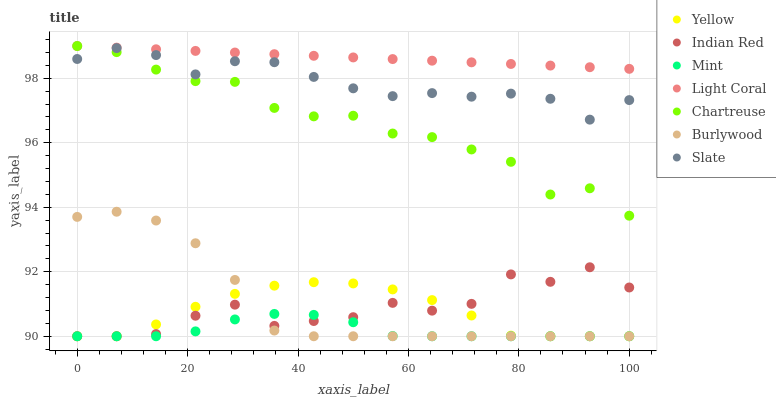Does Mint have the minimum area under the curve?
Answer yes or no. Yes. Does Light Coral have the maximum area under the curve?
Answer yes or no. Yes. Does Slate have the minimum area under the curve?
Answer yes or no. No. Does Slate have the maximum area under the curve?
Answer yes or no. No. Is Light Coral the smoothest?
Answer yes or no. Yes. Is Indian Red the roughest?
Answer yes or no. Yes. Is Slate the smoothest?
Answer yes or no. No. Is Slate the roughest?
Answer yes or no. No. Does Burlywood have the lowest value?
Answer yes or no. Yes. Does Slate have the lowest value?
Answer yes or no. No. Does Chartreuse have the highest value?
Answer yes or no. Yes. Does Slate have the highest value?
Answer yes or no. No. Is Yellow less than Slate?
Answer yes or no. Yes. Is Light Coral greater than Indian Red?
Answer yes or no. Yes. Does Light Coral intersect Chartreuse?
Answer yes or no. Yes. Is Light Coral less than Chartreuse?
Answer yes or no. No. Is Light Coral greater than Chartreuse?
Answer yes or no. No. Does Yellow intersect Slate?
Answer yes or no. No. 